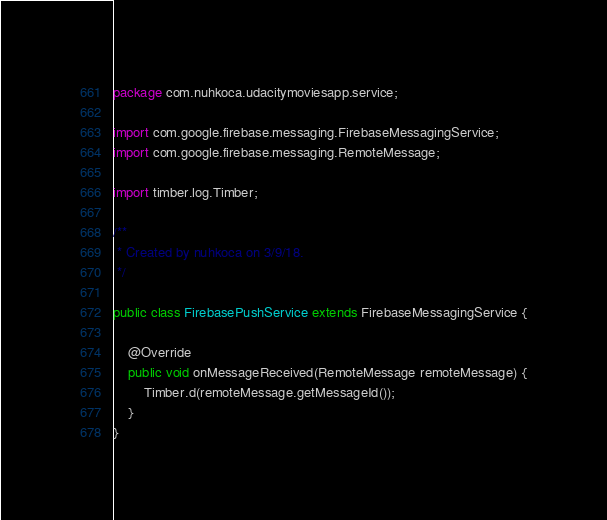Convert code to text. <code><loc_0><loc_0><loc_500><loc_500><_Java_>package com.nuhkoca.udacitymoviesapp.service;

import com.google.firebase.messaging.FirebaseMessagingService;
import com.google.firebase.messaging.RemoteMessage;

import timber.log.Timber;

/**
 * Created by nuhkoca on 3/9/18.
 */

public class FirebasePushService extends FirebaseMessagingService {

    @Override
    public void onMessageReceived(RemoteMessage remoteMessage) {
        Timber.d(remoteMessage.getMessageId());
    }
}</code> 